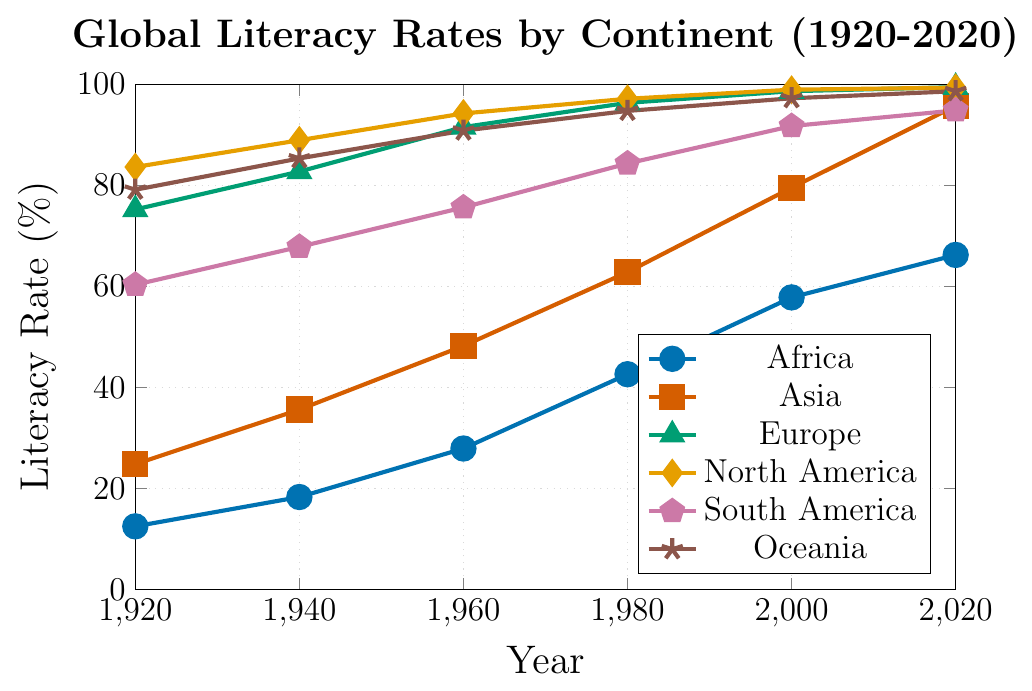What was the literacy rate in Europe in 1960? From the plot, locate the point corresponding to Europe in the year 1960. Read the y-axis value for this point.
Answer: 91.5% Which continent had the highest literacy rate in 1940? Identify the points for all continents in the year 1940 from the plot and compare their y-axis values. North America had the highest point.
Answer: North America By how many percentage points did the literacy rate in Africa increase from 1920 to 2020? Subtract the literacy rate of Africa in 1920 from the literacy rate of Africa in 2020: 66.2% - 12.5% = 53.7%
Answer: 53.7% Which continent showed the most significant increase in literacy rates between 2000 and 2020? Find the difference in literacy rates for each continent between the years 2000 and 2020 and compare them. Asia had the largest increase: 95.7% - 79.5% = 16.2%
Answer: Asia Compare the literacy rates of South America and Oceania in 2020. Which one is higher? Locate the 2020 points for South America and Oceania and compare their y-axis values. Oceania has a higher value.
Answer: Oceania What is the average literacy rate in North America over the time periods shown? Sum the literacy rates of North America for all given years and divide by the number of years (83.6 + 88.9 + 94.2 + 97.1 + 98.9 + 99.3) / 6 = 93.67%
Answer: 93.67% Which continent had a literacy rate closest to 80% in 2000, and what was the exact rate? Locate the 2000 points for all continents and find the one closest to 80%. Asia is closest with a rate of 79.5%.
Answer: Asia, 79.5% How did the literacy rate of Asia change from 1940 to 1960? Find the literacy rates of Asia in 1940 and 1960. Subtract the 1940 rate from the 1960 rate: 48.2% - 35.6% = 12.6%
Answer: 12.6% In which year did Europe reach a literacy rate of 98.6%? Search for the year where Europe's literacy rate plot point matches 98.6%. That year is 2000.
Answer: 2000 Compare the literacy rate trends of Africa and South America between 1960 and 2000. Which continent had a more significant percentage increase? Calculate the increase for both continents: Africa: 57.8% - 27.9% = 29.9%, South America: 91.7% - 75.6% = 16.1%. Africa had a more significant increase.
Answer: Africa 